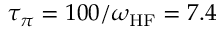Convert formula to latex. <formula><loc_0><loc_0><loc_500><loc_500>\tau _ { \pi } = 1 0 0 / \omega _ { H F } = 7 . 4</formula> 